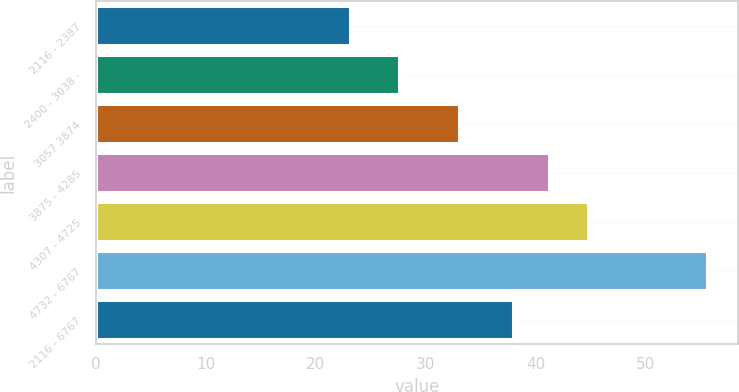<chart> <loc_0><loc_0><loc_500><loc_500><bar_chart><fcel>2116 - 2387<fcel>2400 - 3038 -<fcel>3057 3874<fcel>3875 - 4285<fcel>4307 - 4725<fcel>4732 - 6767<fcel>2116 - 6767<nl><fcel>23.1<fcel>27.57<fcel>33.01<fcel>41.2<fcel>44.73<fcel>55.59<fcel>37.95<nl></chart> 